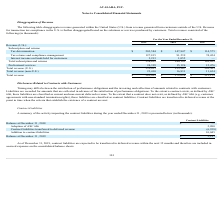From Avalara's financial document, What are the total revenue earned in 2017 and 2018 respectively? The document shows two values: $213,159 and $272,098 (in thousands). From the document: "Total revenue $ 382,421 $ 272,098 $ 213,159 Total revenue $ 382,421 $ 272,098 $ 213,159..." Also, What are the total revenue earned in 2019 and 2018 respectively? The document shows two values: $382,421 and $272,098 (in thousands). From the document: "Total revenue $ 382,421 $ 272,098 $ 213,159 Total revenue $ 382,421 $ 272,098 $ 213,159..." Also, What are the revenue generated from the U.S. in 2018 and 2019 respectively? The document shows two values: 255,267 and 359,011 (in thousands). From the document: "Total revenue (U.S.) 359,011 255,267 201,505 Total revenue (U.S.) 359,011 255,267 201,505..." Also, can you calculate: What is the percentage change in total revenue between 2017 and 2018? To answer this question, I need to perform calculations using the financial data. The calculation is: (272,098 - 213,159)/213,159 , which equals 27.65 (percentage). This is based on the information: "Total revenue $ 382,421 $ 272,098 $ 213,159 Total revenue $ 382,421 $ 272,098 $ 213,159..." The key data points involved are: 213,159, 272,098. Also, can you calculate: What is the percentage change in total revenue between 2018 and 2019? To answer this question, I need to perform calculations using the financial data. The calculation is: (382,421 - 272,098)/272,098 , which equals 40.55 (percentage). This is based on the information: "Total revenue $ 382,421 $ 272,098 $ 213,159 Total revenue $ 382,421 $ 272,098 $ 213,159..." The key data points involved are: 272,098, 382,421. Also, can you calculate: What is the value of the U.S. generated revenue as a percentage of the 2018 total revenue? Based on the calculation: 255,267/272,098 , the result is 93.81 (percentage). This is based on the information: "Total revenue (U.S.) 359,011 255,267 201,505 Total revenue $ 382,421 $ 272,098 $ 213,159..." The key data points involved are: 255,267, 272,098. 